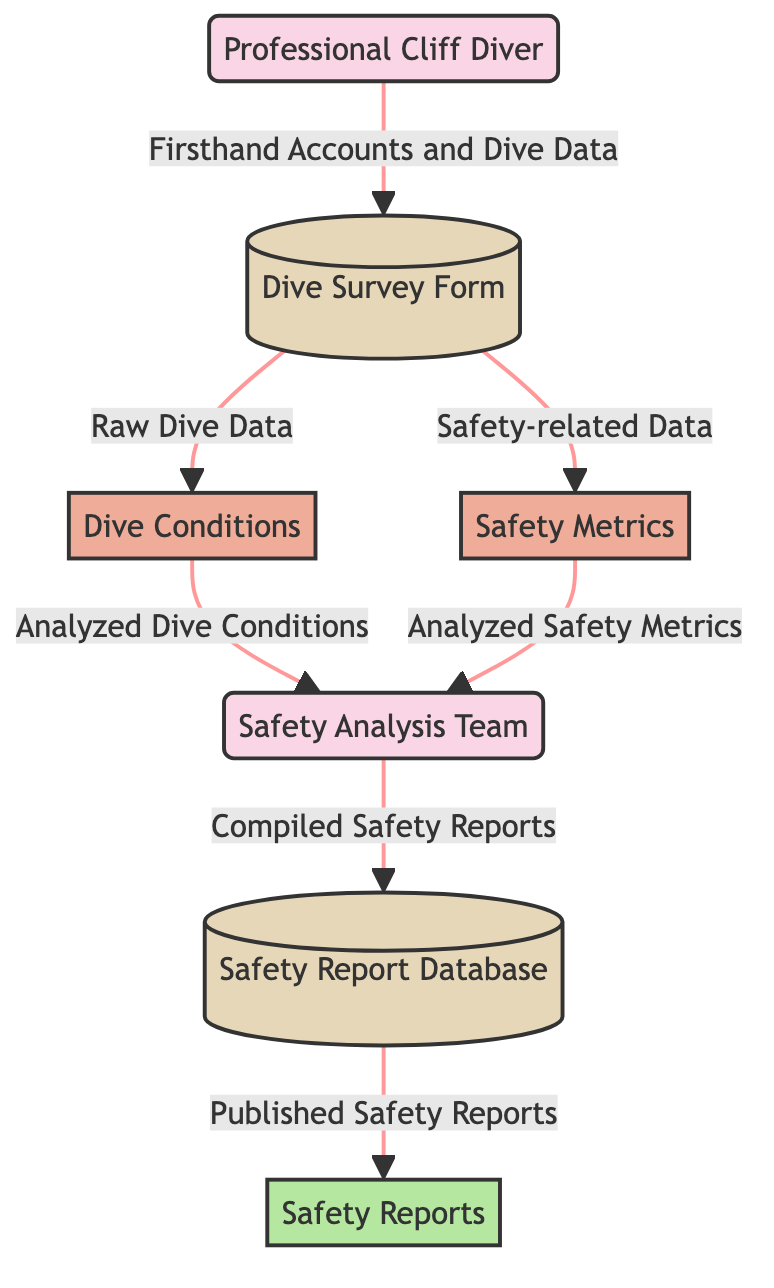What is the first external entity in the diagram? The first external entity listed is "Professional Cliff Diver". This can be directly identified at the beginning of the diagram where the external entities are shown.
Answer: Professional Cliff Diver How many data stores are present in the diagram? There are three data stores indicated: "Dive Survey Form", "Safety Report Database", and the description of each confirms they are categorized as data stores. Thus, we count three.
Answer: 3 Which process receives raw dive data from the Dive Survey Form? The process "Dive Conditions" is directly connected to the "Dive Survey Form" with an arrow indicating the flow of raw dive data. Thus, it is the first process receiving this data.
Answer: Dive Conditions Who is responsible for analyzing the dive conditions and safety metrics? The "Safety Analysis Team" has incoming arrows from both "Dive Conditions" and "Safety Metrics" indicating it is the group responsible for analyzing data on these metrics.
Answer: Safety Analysis Team What do the Safety Analysis Team compile into the Safety Report Database? The team compiles "Safety Reports" as indicated by the flow leading from the "Safety Analysis Team" to the "Safety Report Database", confirming this action.
Answer: Compiled Safety Reports What is the final output of the workflow represented in the diagram? The output node is "Safety Reports," and this conclusion is derived from the flow that originates from the "Safety Report Database" leading to this output.
Answer: Safety Reports How many flows connect the Dive Survey Form to other processes? The "Dive Survey Form" has two flows diverging to "Dive Conditions" and "Safety Metrics," indicating two distinct connections to other processes.
Answer: 2 What type of information does the Dive Survey Form collect? The "Dive Survey Form" collects "Firsthand Accounts and Dive Data," which is specified as the data type flowing into the form.
Answer: Firsthand Accounts and Dive Data Which data store receives published safety reports? The "Safety Report Database" is the data store that receives the "Published Safety Reports" based on the flow indicated toward it from the node above.
Answer: Safety Report Database 